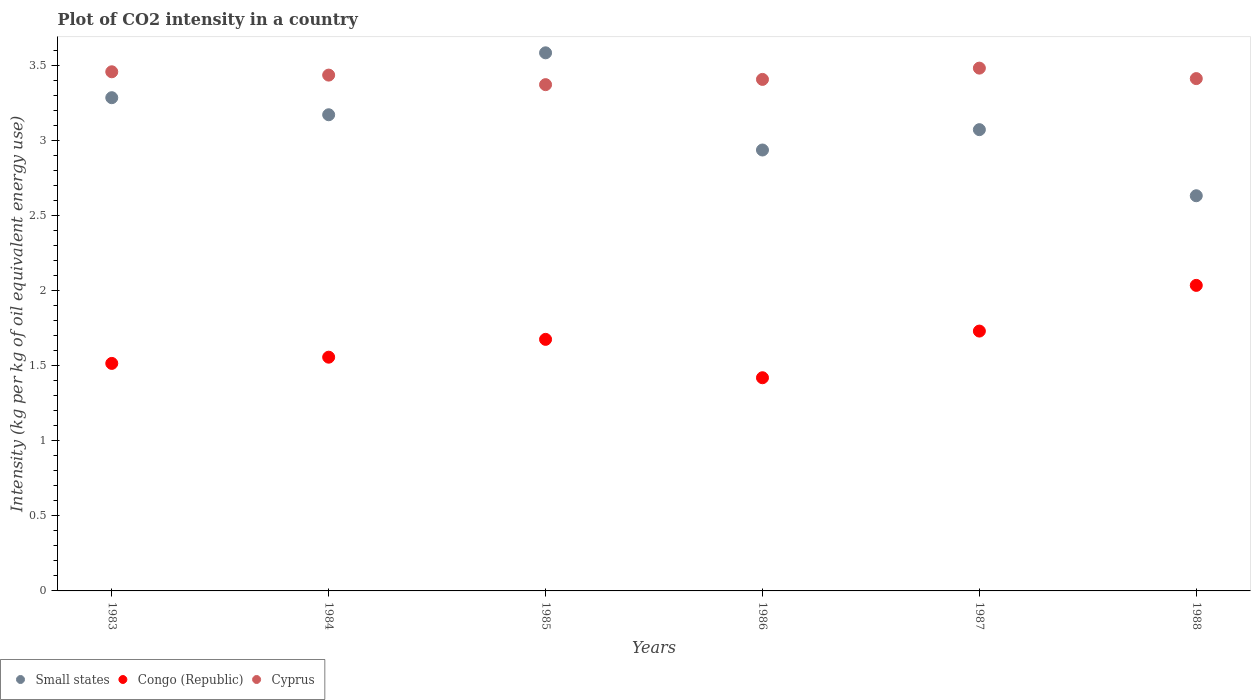How many different coloured dotlines are there?
Offer a very short reply. 3. Is the number of dotlines equal to the number of legend labels?
Offer a very short reply. Yes. What is the CO2 intensity in in Congo (Republic) in 1986?
Your response must be concise. 1.42. Across all years, what is the maximum CO2 intensity in in Small states?
Offer a very short reply. 3.59. Across all years, what is the minimum CO2 intensity in in Cyprus?
Make the answer very short. 3.37. In which year was the CO2 intensity in in Cyprus maximum?
Your response must be concise. 1987. What is the total CO2 intensity in in Cyprus in the graph?
Offer a terse response. 20.58. What is the difference between the CO2 intensity in in Cyprus in 1983 and that in 1986?
Your answer should be very brief. 0.05. What is the difference between the CO2 intensity in in Congo (Republic) in 1988 and the CO2 intensity in in Small states in 1987?
Your response must be concise. -1.04. What is the average CO2 intensity in in Small states per year?
Offer a very short reply. 3.12. In the year 1985, what is the difference between the CO2 intensity in in Congo (Republic) and CO2 intensity in in Small states?
Provide a succinct answer. -1.91. What is the ratio of the CO2 intensity in in Small states in 1983 to that in 1987?
Your answer should be compact. 1.07. What is the difference between the highest and the second highest CO2 intensity in in Cyprus?
Provide a short and direct response. 0.02. What is the difference between the highest and the lowest CO2 intensity in in Small states?
Make the answer very short. 0.95. In how many years, is the CO2 intensity in in Congo (Republic) greater than the average CO2 intensity in in Congo (Republic) taken over all years?
Your answer should be very brief. 3. Does the CO2 intensity in in Small states monotonically increase over the years?
Provide a succinct answer. No. Is the CO2 intensity in in Small states strictly greater than the CO2 intensity in in Cyprus over the years?
Your response must be concise. No. Is the CO2 intensity in in Small states strictly less than the CO2 intensity in in Cyprus over the years?
Make the answer very short. No. What is the difference between two consecutive major ticks on the Y-axis?
Offer a very short reply. 0.5. Does the graph contain grids?
Your answer should be compact. No. How many legend labels are there?
Offer a terse response. 3. How are the legend labels stacked?
Make the answer very short. Horizontal. What is the title of the graph?
Provide a succinct answer. Plot of CO2 intensity in a country. What is the label or title of the X-axis?
Give a very brief answer. Years. What is the label or title of the Y-axis?
Your answer should be very brief. Intensity (kg per kg of oil equivalent energy use). What is the Intensity (kg per kg of oil equivalent energy use) in Small states in 1983?
Your answer should be compact. 3.29. What is the Intensity (kg per kg of oil equivalent energy use) in Congo (Republic) in 1983?
Your answer should be compact. 1.52. What is the Intensity (kg per kg of oil equivalent energy use) in Cyprus in 1983?
Your answer should be very brief. 3.46. What is the Intensity (kg per kg of oil equivalent energy use) of Small states in 1984?
Provide a succinct answer. 3.17. What is the Intensity (kg per kg of oil equivalent energy use) of Congo (Republic) in 1984?
Keep it short and to the point. 1.56. What is the Intensity (kg per kg of oil equivalent energy use) in Cyprus in 1984?
Make the answer very short. 3.44. What is the Intensity (kg per kg of oil equivalent energy use) of Small states in 1985?
Ensure brevity in your answer.  3.59. What is the Intensity (kg per kg of oil equivalent energy use) of Congo (Republic) in 1985?
Offer a very short reply. 1.68. What is the Intensity (kg per kg of oil equivalent energy use) in Cyprus in 1985?
Offer a terse response. 3.37. What is the Intensity (kg per kg of oil equivalent energy use) in Small states in 1986?
Provide a succinct answer. 2.94. What is the Intensity (kg per kg of oil equivalent energy use) in Congo (Republic) in 1986?
Your answer should be compact. 1.42. What is the Intensity (kg per kg of oil equivalent energy use) of Cyprus in 1986?
Your answer should be very brief. 3.41. What is the Intensity (kg per kg of oil equivalent energy use) of Small states in 1987?
Your response must be concise. 3.07. What is the Intensity (kg per kg of oil equivalent energy use) of Congo (Republic) in 1987?
Your answer should be very brief. 1.73. What is the Intensity (kg per kg of oil equivalent energy use) in Cyprus in 1987?
Your response must be concise. 3.48. What is the Intensity (kg per kg of oil equivalent energy use) in Small states in 1988?
Your answer should be compact. 2.63. What is the Intensity (kg per kg of oil equivalent energy use) of Congo (Republic) in 1988?
Make the answer very short. 2.04. What is the Intensity (kg per kg of oil equivalent energy use) in Cyprus in 1988?
Offer a very short reply. 3.41. Across all years, what is the maximum Intensity (kg per kg of oil equivalent energy use) of Small states?
Your answer should be very brief. 3.59. Across all years, what is the maximum Intensity (kg per kg of oil equivalent energy use) of Congo (Republic)?
Provide a succinct answer. 2.04. Across all years, what is the maximum Intensity (kg per kg of oil equivalent energy use) in Cyprus?
Make the answer very short. 3.48. Across all years, what is the minimum Intensity (kg per kg of oil equivalent energy use) in Small states?
Keep it short and to the point. 2.63. Across all years, what is the minimum Intensity (kg per kg of oil equivalent energy use) in Congo (Republic)?
Provide a short and direct response. 1.42. Across all years, what is the minimum Intensity (kg per kg of oil equivalent energy use) of Cyprus?
Ensure brevity in your answer.  3.37. What is the total Intensity (kg per kg of oil equivalent energy use) in Small states in the graph?
Give a very brief answer. 18.69. What is the total Intensity (kg per kg of oil equivalent energy use) in Congo (Republic) in the graph?
Give a very brief answer. 9.94. What is the total Intensity (kg per kg of oil equivalent energy use) of Cyprus in the graph?
Keep it short and to the point. 20.58. What is the difference between the Intensity (kg per kg of oil equivalent energy use) of Small states in 1983 and that in 1984?
Your response must be concise. 0.11. What is the difference between the Intensity (kg per kg of oil equivalent energy use) in Congo (Republic) in 1983 and that in 1984?
Provide a succinct answer. -0.04. What is the difference between the Intensity (kg per kg of oil equivalent energy use) in Cyprus in 1983 and that in 1984?
Provide a short and direct response. 0.02. What is the difference between the Intensity (kg per kg of oil equivalent energy use) in Small states in 1983 and that in 1985?
Your answer should be compact. -0.3. What is the difference between the Intensity (kg per kg of oil equivalent energy use) of Congo (Republic) in 1983 and that in 1985?
Make the answer very short. -0.16. What is the difference between the Intensity (kg per kg of oil equivalent energy use) in Cyprus in 1983 and that in 1985?
Offer a very short reply. 0.09. What is the difference between the Intensity (kg per kg of oil equivalent energy use) of Small states in 1983 and that in 1986?
Give a very brief answer. 0.35. What is the difference between the Intensity (kg per kg of oil equivalent energy use) in Congo (Republic) in 1983 and that in 1986?
Keep it short and to the point. 0.1. What is the difference between the Intensity (kg per kg of oil equivalent energy use) in Cyprus in 1983 and that in 1986?
Offer a very short reply. 0.05. What is the difference between the Intensity (kg per kg of oil equivalent energy use) of Small states in 1983 and that in 1987?
Offer a very short reply. 0.21. What is the difference between the Intensity (kg per kg of oil equivalent energy use) of Congo (Republic) in 1983 and that in 1987?
Ensure brevity in your answer.  -0.22. What is the difference between the Intensity (kg per kg of oil equivalent energy use) of Cyprus in 1983 and that in 1987?
Give a very brief answer. -0.02. What is the difference between the Intensity (kg per kg of oil equivalent energy use) of Small states in 1983 and that in 1988?
Ensure brevity in your answer.  0.65. What is the difference between the Intensity (kg per kg of oil equivalent energy use) of Congo (Republic) in 1983 and that in 1988?
Your response must be concise. -0.52. What is the difference between the Intensity (kg per kg of oil equivalent energy use) of Cyprus in 1983 and that in 1988?
Ensure brevity in your answer.  0.05. What is the difference between the Intensity (kg per kg of oil equivalent energy use) of Small states in 1984 and that in 1985?
Offer a very short reply. -0.41. What is the difference between the Intensity (kg per kg of oil equivalent energy use) in Congo (Republic) in 1984 and that in 1985?
Keep it short and to the point. -0.12. What is the difference between the Intensity (kg per kg of oil equivalent energy use) of Cyprus in 1984 and that in 1985?
Offer a very short reply. 0.06. What is the difference between the Intensity (kg per kg of oil equivalent energy use) of Small states in 1984 and that in 1986?
Provide a succinct answer. 0.23. What is the difference between the Intensity (kg per kg of oil equivalent energy use) of Congo (Republic) in 1984 and that in 1986?
Your answer should be very brief. 0.14. What is the difference between the Intensity (kg per kg of oil equivalent energy use) in Cyprus in 1984 and that in 1986?
Give a very brief answer. 0.03. What is the difference between the Intensity (kg per kg of oil equivalent energy use) in Small states in 1984 and that in 1987?
Your answer should be very brief. 0.1. What is the difference between the Intensity (kg per kg of oil equivalent energy use) of Congo (Republic) in 1984 and that in 1987?
Your answer should be very brief. -0.17. What is the difference between the Intensity (kg per kg of oil equivalent energy use) of Cyprus in 1984 and that in 1987?
Your answer should be very brief. -0.05. What is the difference between the Intensity (kg per kg of oil equivalent energy use) of Small states in 1984 and that in 1988?
Give a very brief answer. 0.54. What is the difference between the Intensity (kg per kg of oil equivalent energy use) of Congo (Republic) in 1984 and that in 1988?
Your response must be concise. -0.48. What is the difference between the Intensity (kg per kg of oil equivalent energy use) in Cyprus in 1984 and that in 1988?
Provide a short and direct response. 0.02. What is the difference between the Intensity (kg per kg of oil equivalent energy use) in Small states in 1985 and that in 1986?
Provide a succinct answer. 0.65. What is the difference between the Intensity (kg per kg of oil equivalent energy use) of Congo (Republic) in 1985 and that in 1986?
Provide a short and direct response. 0.26. What is the difference between the Intensity (kg per kg of oil equivalent energy use) of Cyprus in 1985 and that in 1986?
Keep it short and to the point. -0.03. What is the difference between the Intensity (kg per kg of oil equivalent energy use) in Small states in 1985 and that in 1987?
Provide a short and direct response. 0.51. What is the difference between the Intensity (kg per kg of oil equivalent energy use) in Congo (Republic) in 1985 and that in 1987?
Make the answer very short. -0.06. What is the difference between the Intensity (kg per kg of oil equivalent energy use) in Cyprus in 1985 and that in 1987?
Provide a short and direct response. -0.11. What is the difference between the Intensity (kg per kg of oil equivalent energy use) in Small states in 1985 and that in 1988?
Offer a terse response. 0.95. What is the difference between the Intensity (kg per kg of oil equivalent energy use) of Congo (Republic) in 1985 and that in 1988?
Your answer should be very brief. -0.36. What is the difference between the Intensity (kg per kg of oil equivalent energy use) of Cyprus in 1985 and that in 1988?
Offer a terse response. -0.04. What is the difference between the Intensity (kg per kg of oil equivalent energy use) of Small states in 1986 and that in 1987?
Provide a succinct answer. -0.14. What is the difference between the Intensity (kg per kg of oil equivalent energy use) of Congo (Republic) in 1986 and that in 1987?
Offer a very short reply. -0.31. What is the difference between the Intensity (kg per kg of oil equivalent energy use) in Cyprus in 1986 and that in 1987?
Provide a short and direct response. -0.08. What is the difference between the Intensity (kg per kg of oil equivalent energy use) of Small states in 1986 and that in 1988?
Give a very brief answer. 0.3. What is the difference between the Intensity (kg per kg of oil equivalent energy use) in Congo (Republic) in 1986 and that in 1988?
Your answer should be very brief. -0.62. What is the difference between the Intensity (kg per kg of oil equivalent energy use) in Cyprus in 1986 and that in 1988?
Provide a short and direct response. -0.01. What is the difference between the Intensity (kg per kg of oil equivalent energy use) in Small states in 1987 and that in 1988?
Your answer should be compact. 0.44. What is the difference between the Intensity (kg per kg of oil equivalent energy use) in Congo (Republic) in 1987 and that in 1988?
Offer a terse response. -0.3. What is the difference between the Intensity (kg per kg of oil equivalent energy use) in Cyprus in 1987 and that in 1988?
Provide a succinct answer. 0.07. What is the difference between the Intensity (kg per kg of oil equivalent energy use) of Small states in 1983 and the Intensity (kg per kg of oil equivalent energy use) of Congo (Republic) in 1984?
Provide a short and direct response. 1.73. What is the difference between the Intensity (kg per kg of oil equivalent energy use) of Small states in 1983 and the Intensity (kg per kg of oil equivalent energy use) of Cyprus in 1984?
Offer a terse response. -0.15. What is the difference between the Intensity (kg per kg of oil equivalent energy use) in Congo (Republic) in 1983 and the Intensity (kg per kg of oil equivalent energy use) in Cyprus in 1984?
Give a very brief answer. -1.92. What is the difference between the Intensity (kg per kg of oil equivalent energy use) of Small states in 1983 and the Intensity (kg per kg of oil equivalent energy use) of Congo (Republic) in 1985?
Your answer should be very brief. 1.61. What is the difference between the Intensity (kg per kg of oil equivalent energy use) in Small states in 1983 and the Intensity (kg per kg of oil equivalent energy use) in Cyprus in 1985?
Give a very brief answer. -0.09. What is the difference between the Intensity (kg per kg of oil equivalent energy use) of Congo (Republic) in 1983 and the Intensity (kg per kg of oil equivalent energy use) of Cyprus in 1985?
Your answer should be very brief. -1.86. What is the difference between the Intensity (kg per kg of oil equivalent energy use) in Small states in 1983 and the Intensity (kg per kg of oil equivalent energy use) in Congo (Republic) in 1986?
Your answer should be compact. 1.87. What is the difference between the Intensity (kg per kg of oil equivalent energy use) in Small states in 1983 and the Intensity (kg per kg of oil equivalent energy use) in Cyprus in 1986?
Keep it short and to the point. -0.12. What is the difference between the Intensity (kg per kg of oil equivalent energy use) of Congo (Republic) in 1983 and the Intensity (kg per kg of oil equivalent energy use) of Cyprus in 1986?
Offer a very short reply. -1.89. What is the difference between the Intensity (kg per kg of oil equivalent energy use) of Small states in 1983 and the Intensity (kg per kg of oil equivalent energy use) of Congo (Republic) in 1987?
Provide a succinct answer. 1.56. What is the difference between the Intensity (kg per kg of oil equivalent energy use) of Small states in 1983 and the Intensity (kg per kg of oil equivalent energy use) of Cyprus in 1987?
Make the answer very short. -0.2. What is the difference between the Intensity (kg per kg of oil equivalent energy use) in Congo (Republic) in 1983 and the Intensity (kg per kg of oil equivalent energy use) in Cyprus in 1987?
Offer a very short reply. -1.97. What is the difference between the Intensity (kg per kg of oil equivalent energy use) in Small states in 1983 and the Intensity (kg per kg of oil equivalent energy use) in Congo (Republic) in 1988?
Your answer should be very brief. 1.25. What is the difference between the Intensity (kg per kg of oil equivalent energy use) of Small states in 1983 and the Intensity (kg per kg of oil equivalent energy use) of Cyprus in 1988?
Offer a very short reply. -0.13. What is the difference between the Intensity (kg per kg of oil equivalent energy use) in Congo (Republic) in 1983 and the Intensity (kg per kg of oil equivalent energy use) in Cyprus in 1988?
Provide a succinct answer. -1.9. What is the difference between the Intensity (kg per kg of oil equivalent energy use) in Small states in 1984 and the Intensity (kg per kg of oil equivalent energy use) in Congo (Republic) in 1985?
Keep it short and to the point. 1.5. What is the difference between the Intensity (kg per kg of oil equivalent energy use) in Small states in 1984 and the Intensity (kg per kg of oil equivalent energy use) in Cyprus in 1985?
Keep it short and to the point. -0.2. What is the difference between the Intensity (kg per kg of oil equivalent energy use) in Congo (Republic) in 1984 and the Intensity (kg per kg of oil equivalent energy use) in Cyprus in 1985?
Your answer should be compact. -1.82. What is the difference between the Intensity (kg per kg of oil equivalent energy use) in Small states in 1984 and the Intensity (kg per kg of oil equivalent energy use) in Congo (Republic) in 1986?
Keep it short and to the point. 1.75. What is the difference between the Intensity (kg per kg of oil equivalent energy use) of Small states in 1984 and the Intensity (kg per kg of oil equivalent energy use) of Cyprus in 1986?
Provide a short and direct response. -0.24. What is the difference between the Intensity (kg per kg of oil equivalent energy use) in Congo (Republic) in 1984 and the Intensity (kg per kg of oil equivalent energy use) in Cyprus in 1986?
Give a very brief answer. -1.85. What is the difference between the Intensity (kg per kg of oil equivalent energy use) in Small states in 1984 and the Intensity (kg per kg of oil equivalent energy use) in Congo (Republic) in 1987?
Ensure brevity in your answer.  1.44. What is the difference between the Intensity (kg per kg of oil equivalent energy use) of Small states in 1984 and the Intensity (kg per kg of oil equivalent energy use) of Cyprus in 1987?
Your answer should be compact. -0.31. What is the difference between the Intensity (kg per kg of oil equivalent energy use) in Congo (Republic) in 1984 and the Intensity (kg per kg of oil equivalent energy use) in Cyprus in 1987?
Offer a very short reply. -1.93. What is the difference between the Intensity (kg per kg of oil equivalent energy use) in Small states in 1984 and the Intensity (kg per kg of oil equivalent energy use) in Congo (Republic) in 1988?
Your answer should be very brief. 1.14. What is the difference between the Intensity (kg per kg of oil equivalent energy use) of Small states in 1984 and the Intensity (kg per kg of oil equivalent energy use) of Cyprus in 1988?
Offer a very short reply. -0.24. What is the difference between the Intensity (kg per kg of oil equivalent energy use) of Congo (Republic) in 1984 and the Intensity (kg per kg of oil equivalent energy use) of Cyprus in 1988?
Make the answer very short. -1.86. What is the difference between the Intensity (kg per kg of oil equivalent energy use) of Small states in 1985 and the Intensity (kg per kg of oil equivalent energy use) of Congo (Republic) in 1986?
Your answer should be very brief. 2.17. What is the difference between the Intensity (kg per kg of oil equivalent energy use) in Small states in 1985 and the Intensity (kg per kg of oil equivalent energy use) in Cyprus in 1986?
Provide a succinct answer. 0.18. What is the difference between the Intensity (kg per kg of oil equivalent energy use) of Congo (Republic) in 1985 and the Intensity (kg per kg of oil equivalent energy use) of Cyprus in 1986?
Offer a terse response. -1.73. What is the difference between the Intensity (kg per kg of oil equivalent energy use) of Small states in 1985 and the Intensity (kg per kg of oil equivalent energy use) of Congo (Republic) in 1987?
Give a very brief answer. 1.85. What is the difference between the Intensity (kg per kg of oil equivalent energy use) in Small states in 1985 and the Intensity (kg per kg of oil equivalent energy use) in Cyprus in 1987?
Offer a very short reply. 0.1. What is the difference between the Intensity (kg per kg of oil equivalent energy use) of Congo (Republic) in 1985 and the Intensity (kg per kg of oil equivalent energy use) of Cyprus in 1987?
Offer a terse response. -1.81. What is the difference between the Intensity (kg per kg of oil equivalent energy use) of Small states in 1985 and the Intensity (kg per kg of oil equivalent energy use) of Congo (Republic) in 1988?
Your answer should be very brief. 1.55. What is the difference between the Intensity (kg per kg of oil equivalent energy use) of Small states in 1985 and the Intensity (kg per kg of oil equivalent energy use) of Cyprus in 1988?
Your response must be concise. 0.17. What is the difference between the Intensity (kg per kg of oil equivalent energy use) in Congo (Republic) in 1985 and the Intensity (kg per kg of oil equivalent energy use) in Cyprus in 1988?
Your response must be concise. -1.74. What is the difference between the Intensity (kg per kg of oil equivalent energy use) of Small states in 1986 and the Intensity (kg per kg of oil equivalent energy use) of Congo (Republic) in 1987?
Your response must be concise. 1.21. What is the difference between the Intensity (kg per kg of oil equivalent energy use) in Small states in 1986 and the Intensity (kg per kg of oil equivalent energy use) in Cyprus in 1987?
Keep it short and to the point. -0.55. What is the difference between the Intensity (kg per kg of oil equivalent energy use) of Congo (Republic) in 1986 and the Intensity (kg per kg of oil equivalent energy use) of Cyprus in 1987?
Ensure brevity in your answer.  -2.06. What is the difference between the Intensity (kg per kg of oil equivalent energy use) in Small states in 1986 and the Intensity (kg per kg of oil equivalent energy use) in Congo (Republic) in 1988?
Make the answer very short. 0.9. What is the difference between the Intensity (kg per kg of oil equivalent energy use) in Small states in 1986 and the Intensity (kg per kg of oil equivalent energy use) in Cyprus in 1988?
Your answer should be compact. -0.48. What is the difference between the Intensity (kg per kg of oil equivalent energy use) in Congo (Republic) in 1986 and the Intensity (kg per kg of oil equivalent energy use) in Cyprus in 1988?
Provide a short and direct response. -1.99. What is the difference between the Intensity (kg per kg of oil equivalent energy use) in Small states in 1987 and the Intensity (kg per kg of oil equivalent energy use) in Congo (Republic) in 1988?
Offer a terse response. 1.04. What is the difference between the Intensity (kg per kg of oil equivalent energy use) in Small states in 1987 and the Intensity (kg per kg of oil equivalent energy use) in Cyprus in 1988?
Your answer should be very brief. -0.34. What is the difference between the Intensity (kg per kg of oil equivalent energy use) of Congo (Republic) in 1987 and the Intensity (kg per kg of oil equivalent energy use) of Cyprus in 1988?
Give a very brief answer. -1.68. What is the average Intensity (kg per kg of oil equivalent energy use) in Small states per year?
Provide a short and direct response. 3.12. What is the average Intensity (kg per kg of oil equivalent energy use) in Congo (Republic) per year?
Offer a terse response. 1.66. What is the average Intensity (kg per kg of oil equivalent energy use) in Cyprus per year?
Your response must be concise. 3.43. In the year 1983, what is the difference between the Intensity (kg per kg of oil equivalent energy use) of Small states and Intensity (kg per kg of oil equivalent energy use) of Congo (Republic)?
Your answer should be compact. 1.77. In the year 1983, what is the difference between the Intensity (kg per kg of oil equivalent energy use) of Small states and Intensity (kg per kg of oil equivalent energy use) of Cyprus?
Offer a terse response. -0.17. In the year 1983, what is the difference between the Intensity (kg per kg of oil equivalent energy use) in Congo (Republic) and Intensity (kg per kg of oil equivalent energy use) in Cyprus?
Provide a succinct answer. -1.94. In the year 1984, what is the difference between the Intensity (kg per kg of oil equivalent energy use) in Small states and Intensity (kg per kg of oil equivalent energy use) in Congo (Republic)?
Give a very brief answer. 1.62. In the year 1984, what is the difference between the Intensity (kg per kg of oil equivalent energy use) in Small states and Intensity (kg per kg of oil equivalent energy use) in Cyprus?
Ensure brevity in your answer.  -0.26. In the year 1984, what is the difference between the Intensity (kg per kg of oil equivalent energy use) of Congo (Republic) and Intensity (kg per kg of oil equivalent energy use) of Cyprus?
Your response must be concise. -1.88. In the year 1985, what is the difference between the Intensity (kg per kg of oil equivalent energy use) in Small states and Intensity (kg per kg of oil equivalent energy use) in Congo (Republic)?
Your answer should be compact. 1.91. In the year 1985, what is the difference between the Intensity (kg per kg of oil equivalent energy use) in Small states and Intensity (kg per kg of oil equivalent energy use) in Cyprus?
Make the answer very short. 0.21. In the year 1985, what is the difference between the Intensity (kg per kg of oil equivalent energy use) in Congo (Republic) and Intensity (kg per kg of oil equivalent energy use) in Cyprus?
Your answer should be compact. -1.7. In the year 1986, what is the difference between the Intensity (kg per kg of oil equivalent energy use) in Small states and Intensity (kg per kg of oil equivalent energy use) in Congo (Republic)?
Provide a succinct answer. 1.52. In the year 1986, what is the difference between the Intensity (kg per kg of oil equivalent energy use) in Small states and Intensity (kg per kg of oil equivalent energy use) in Cyprus?
Your response must be concise. -0.47. In the year 1986, what is the difference between the Intensity (kg per kg of oil equivalent energy use) of Congo (Republic) and Intensity (kg per kg of oil equivalent energy use) of Cyprus?
Ensure brevity in your answer.  -1.99. In the year 1987, what is the difference between the Intensity (kg per kg of oil equivalent energy use) of Small states and Intensity (kg per kg of oil equivalent energy use) of Congo (Republic)?
Your answer should be compact. 1.34. In the year 1987, what is the difference between the Intensity (kg per kg of oil equivalent energy use) of Small states and Intensity (kg per kg of oil equivalent energy use) of Cyprus?
Ensure brevity in your answer.  -0.41. In the year 1987, what is the difference between the Intensity (kg per kg of oil equivalent energy use) of Congo (Republic) and Intensity (kg per kg of oil equivalent energy use) of Cyprus?
Provide a short and direct response. -1.75. In the year 1988, what is the difference between the Intensity (kg per kg of oil equivalent energy use) of Small states and Intensity (kg per kg of oil equivalent energy use) of Congo (Republic)?
Your answer should be compact. 0.6. In the year 1988, what is the difference between the Intensity (kg per kg of oil equivalent energy use) of Small states and Intensity (kg per kg of oil equivalent energy use) of Cyprus?
Provide a short and direct response. -0.78. In the year 1988, what is the difference between the Intensity (kg per kg of oil equivalent energy use) in Congo (Republic) and Intensity (kg per kg of oil equivalent energy use) in Cyprus?
Your answer should be very brief. -1.38. What is the ratio of the Intensity (kg per kg of oil equivalent energy use) in Small states in 1983 to that in 1984?
Keep it short and to the point. 1.04. What is the ratio of the Intensity (kg per kg of oil equivalent energy use) in Congo (Republic) in 1983 to that in 1984?
Keep it short and to the point. 0.97. What is the ratio of the Intensity (kg per kg of oil equivalent energy use) in Cyprus in 1983 to that in 1984?
Your answer should be very brief. 1.01. What is the ratio of the Intensity (kg per kg of oil equivalent energy use) in Small states in 1983 to that in 1985?
Make the answer very short. 0.92. What is the ratio of the Intensity (kg per kg of oil equivalent energy use) in Congo (Republic) in 1983 to that in 1985?
Your answer should be very brief. 0.9. What is the ratio of the Intensity (kg per kg of oil equivalent energy use) of Cyprus in 1983 to that in 1985?
Provide a succinct answer. 1.03. What is the ratio of the Intensity (kg per kg of oil equivalent energy use) of Small states in 1983 to that in 1986?
Keep it short and to the point. 1.12. What is the ratio of the Intensity (kg per kg of oil equivalent energy use) of Congo (Republic) in 1983 to that in 1986?
Your response must be concise. 1.07. What is the ratio of the Intensity (kg per kg of oil equivalent energy use) in Cyprus in 1983 to that in 1986?
Ensure brevity in your answer.  1.01. What is the ratio of the Intensity (kg per kg of oil equivalent energy use) in Small states in 1983 to that in 1987?
Offer a terse response. 1.07. What is the ratio of the Intensity (kg per kg of oil equivalent energy use) in Congo (Republic) in 1983 to that in 1987?
Your response must be concise. 0.88. What is the ratio of the Intensity (kg per kg of oil equivalent energy use) in Small states in 1983 to that in 1988?
Offer a terse response. 1.25. What is the ratio of the Intensity (kg per kg of oil equivalent energy use) of Congo (Republic) in 1983 to that in 1988?
Your response must be concise. 0.74. What is the ratio of the Intensity (kg per kg of oil equivalent energy use) in Cyprus in 1983 to that in 1988?
Provide a succinct answer. 1.01. What is the ratio of the Intensity (kg per kg of oil equivalent energy use) of Small states in 1984 to that in 1985?
Offer a terse response. 0.88. What is the ratio of the Intensity (kg per kg of oil equivalent energy use) of Congo (Republic) in 1984 to that in 1985?
Your response must be concise. 0.93. What is the ratio of the Intensity (kg per kg of oil equivalent energy use) in Cyprus in 1984 to that in 1985?
Your answer should be very brief. 1.02. What is the ratio of the Intensity (kg per kg of oil equivalent energy use) in Small states in 1984 to that in 1986?
Offer a very short reply. 1.08. What is the ratio of the Intensity (kg per kg of oil equivalent energy use) in Congo (Republic) in 1984 to that in 1986?
Make the answer very short. 1.1. What is the ratio of the Intensity (kg per kg of oil equivalent energy use) of Cyprus in 1984 to that in 1986?
Provide a succinct answer. 1.01. What is the ratio of the Intensity (kg per kg of oil equivalent energy use) in Small states in 1984 to that in 1987?
Make the answer very short. 1.03. What is the ratio of the Intensity (kg per kg of oil equivalent energy use) in Congo (Republic) in 1984 to that in 1987?
Ensure brevity in your answer.  0.9. What is the ratio of the Intensity (kg per kg of oil equivalent energy use) of Cyprus in 1984 to that in 1987?
Your answer should be compact. 0.99. What is the ratio of the Intensity (kg per kg of oil equivalent energy use) in Small states in 1984 to that in 1988?
Provide a succinct answer. 1.21. What is the ratio of the Intensity (kg per kg of oil equivalent energy use) in Congo (Republic) in 1984 to that in 1988?
Ensure brevity in your answer.  0.77. What is the ratio of the Intensity (kg per kg of oil equivalent energy use) of Cyprus in 1984 to that in 1988?
Ensure brevity in your answer.  1.01. What is the ratio of the Intensity (kg per kg of oil equivalent energy use) in Small states in 1985 to that in 1986?
Make the answer very short. 1.22. What is the ratio of the Intensity (kg per kg of oil equivalent energy use) in Congo (Republic) in 1985 to that in 1986?
Provide a succinct answer. 1.18. What is the ratio of the Intensity (kg per kg of oil equivalent energy use) of Cyprus in 1985 to that in 1986?
Ensure brevity in your answer.  0.99. What is the ratio of the Intensity (kg per kg of oil equivalent energy use) in Small states in 1985 to that in 1987?
Keep it short and to the point. 1.17. What is the ratio of the Intensity (kg per kg of oil equivalent energy use) in Congo (Republic) in 1985 to that in 1987?
Make the answer very short. 0.97. What is the ratio of the Intensity (kg per kg of oil equivalent energy use) in Cyprus in 1985 to that in 1987?
Offer a very short reply. 0.97. What is the ratio of the Intensity (kg per kg of oil equivalent energy use) of Small states in 1985 to that in 1988?
Your answer should be compact. 1.36. What is the ratio of the Intensity (kg per kg of oil equivalent energy use) of Congo (Republic) in 1985 to that in 1988?
Your answer should be compact. 0.82. What is the ratio of the Intensity (kg per kg of oil equivalent energy use) in Small states in 1986 to that in 1987?
Ensure brevity in your answer.  0.96. What is the ratio of the Intensity (kg per kg of oil equivalent energy use) of Congo (Republic) in 1986 to that in 1987?
Keep it short and to the point. 0.82. What is the ratio of the Intensity (kg per kg of oil equivalent energy use) in Cyprus in 1986 to that in 1987?
Give a very brief answer. 0.98. What is the ratio of the Intensity (kg per kg of oil equivalent energy use) in Small states in 1986 to that in 1988?
Make the answer very short. 1.12. What is the ratio of the Intensity (kg per kg of oil equivalent energy use) in Congo (Republic) in 1986 to that in 1988?
Offer a very short reply. 0.7. What is the ratio of the Intensity (kg per kg of oil equivalent energy use) of Cyprus in 1986 to that in 1988?
Your answer should be compact. 1. What is the ratio of the Intensity (kg per kg of oil equivalent energy use) in Small states in 1987 to that in 1988?
Your answer should be compact. 1.17. What is the ratio of the Intensity (kg per kg of oil equivalent energy use) in Congo (Republic) in 1987 to that in 1988?
Your answer should be compact. 0.85. What is the ratio of the Intensity (kg per kg of oil equivalent energy use) in Cyprus in 1987 to that in 1988?
Your answer should be compact. 1.02. What is the difference between the highest and the second highest Intensity (kg per kg of oil equivalent energy use) in Small states?
Offer a terse response. 0.3. What is the difference between the highest and the second highest Intensity (kg per kg of oil equivalent energy use) of Congo (Republic)?
Make the answer very short. 0.3. What is the difference between the highest and the second highest Intensity (kg per kg of oil equivalent energy use) in Cyprus?
Make the answer very short. 0.02. What is the difference between the highest and the lowest Intensity (kg per kg of oil equivalent energy use) of Congo (Republic)?
Provide a short and direct response. 0.62. What is the difference between the highest and the lowest Intensity (kg per kg of oil equivalent energy use) of Cyprus?
Your response must be concise. 0.11. 